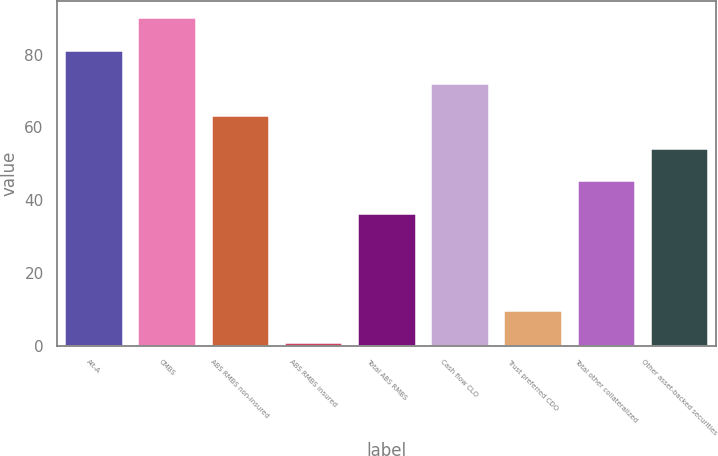Convert chart to OTSL. <chart><loc_0><loc_0><loc_500><loc_500><bar_chart><fcel>Alt-A<fcel>CMBS<fcel>ABS RMBS non-insured<fcel>ABS RMBS insured<fcel>Total ABS RMBS<fcel>Cash flow CLO<fcel>Trust preferred CDO<fcel>Total other collateralized<fcel>Other asset-backed securities<nl><fcel>81.2<fcel>90.3<fcel>63.32<fcel>0.9<fcel>36.5<fcel>72.26<fcel>9.84<fcel>45.44<fcel>54.38<nl></chart> 